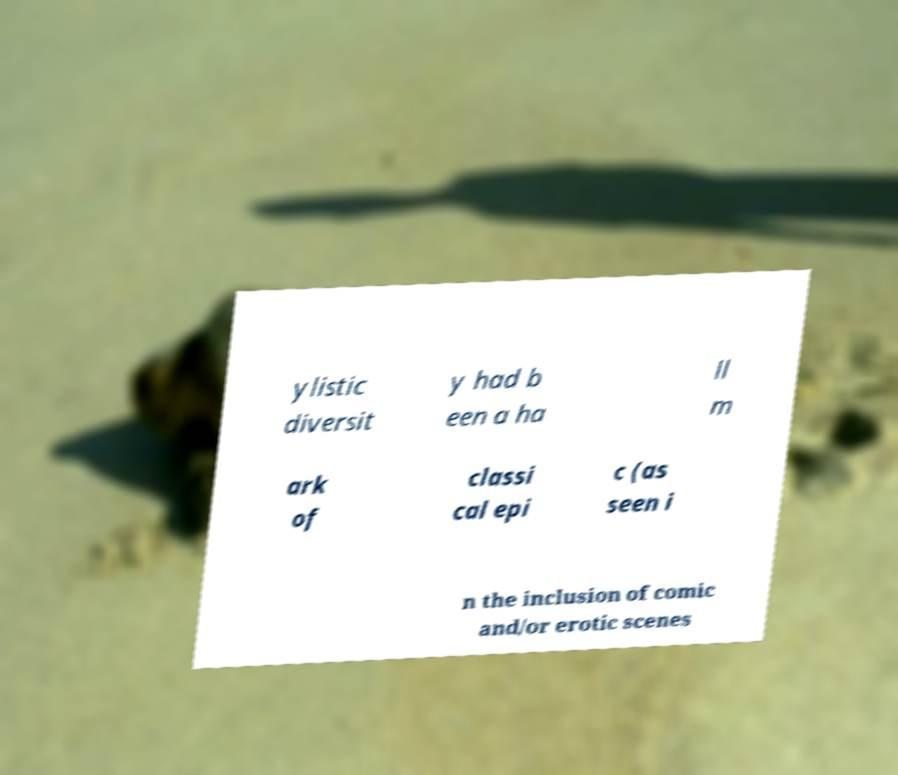Could you extract and type out the text from this image? ylistic diversit y had b een a ha ll m ark of classi cal epi c (as seen i n the inclusion of comic and/or erotic scenes 